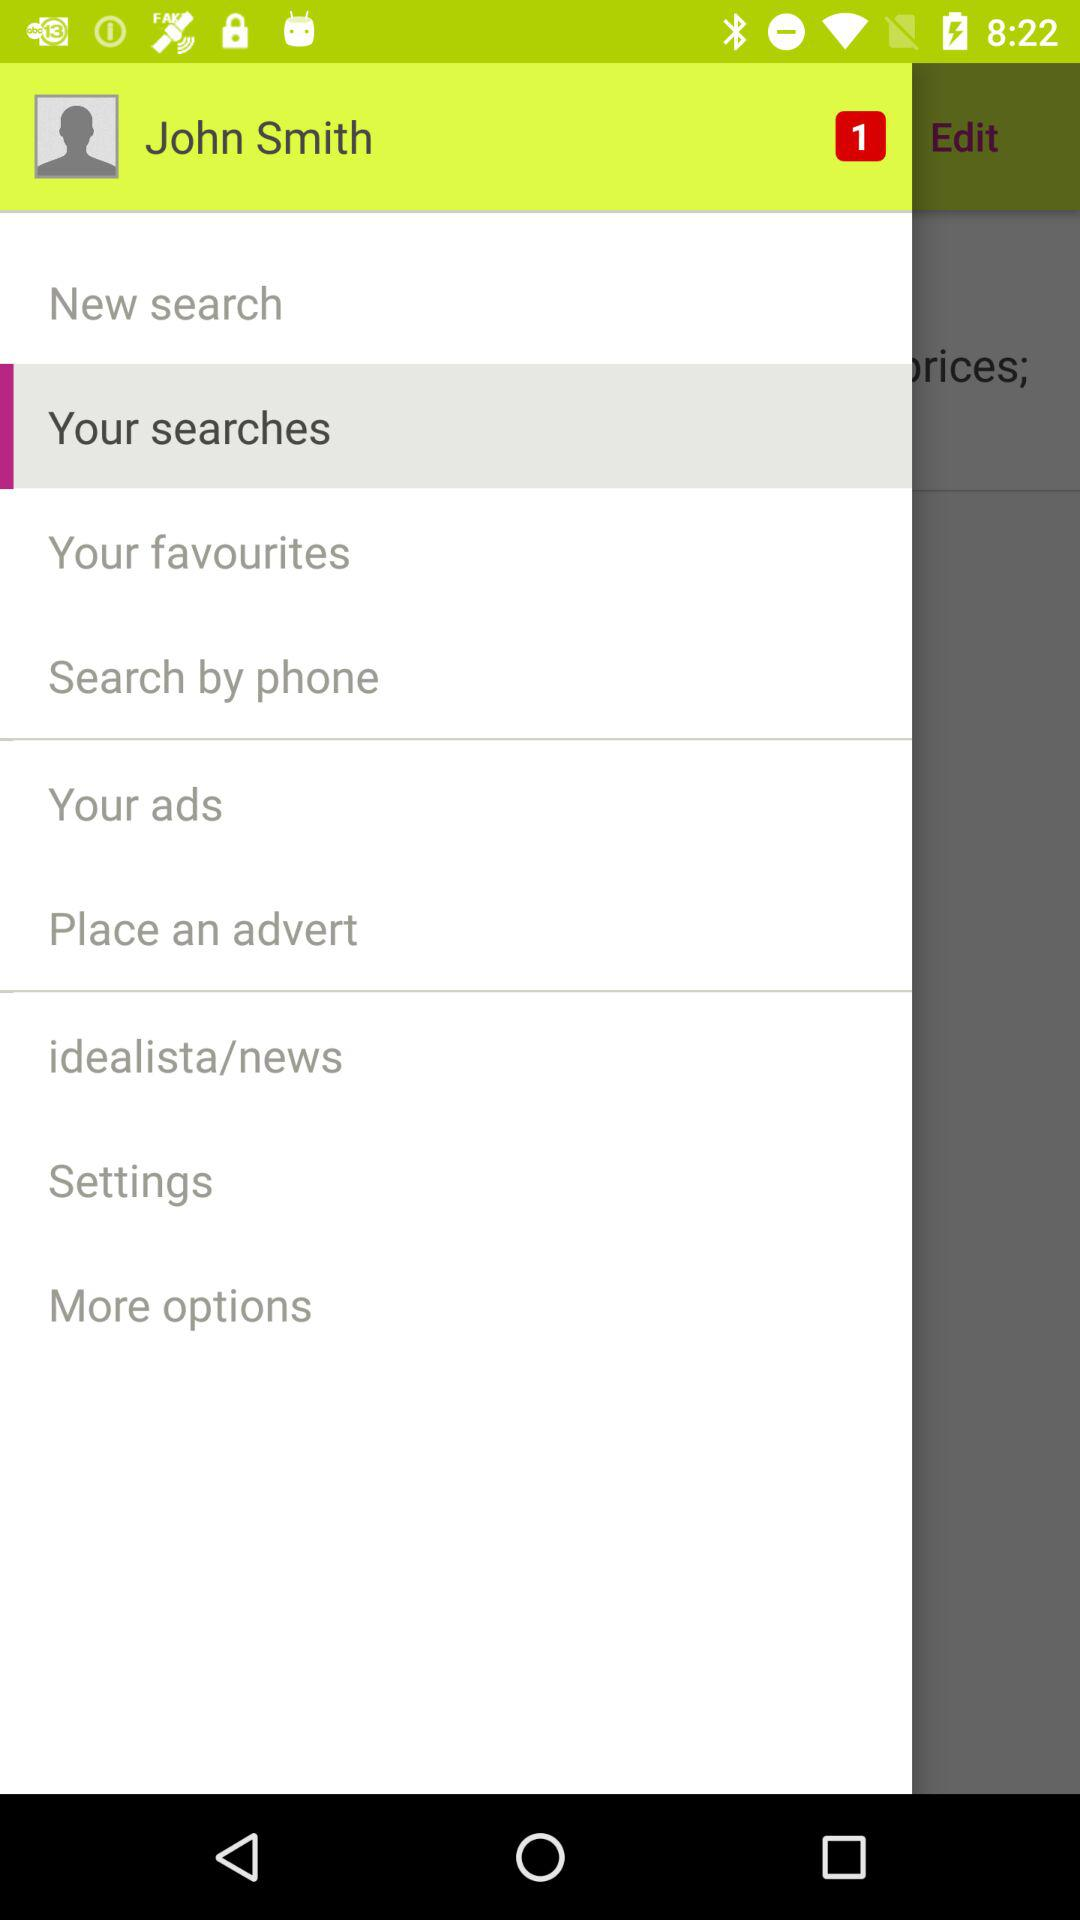Which option is selected? The selected option is "Your searches". 